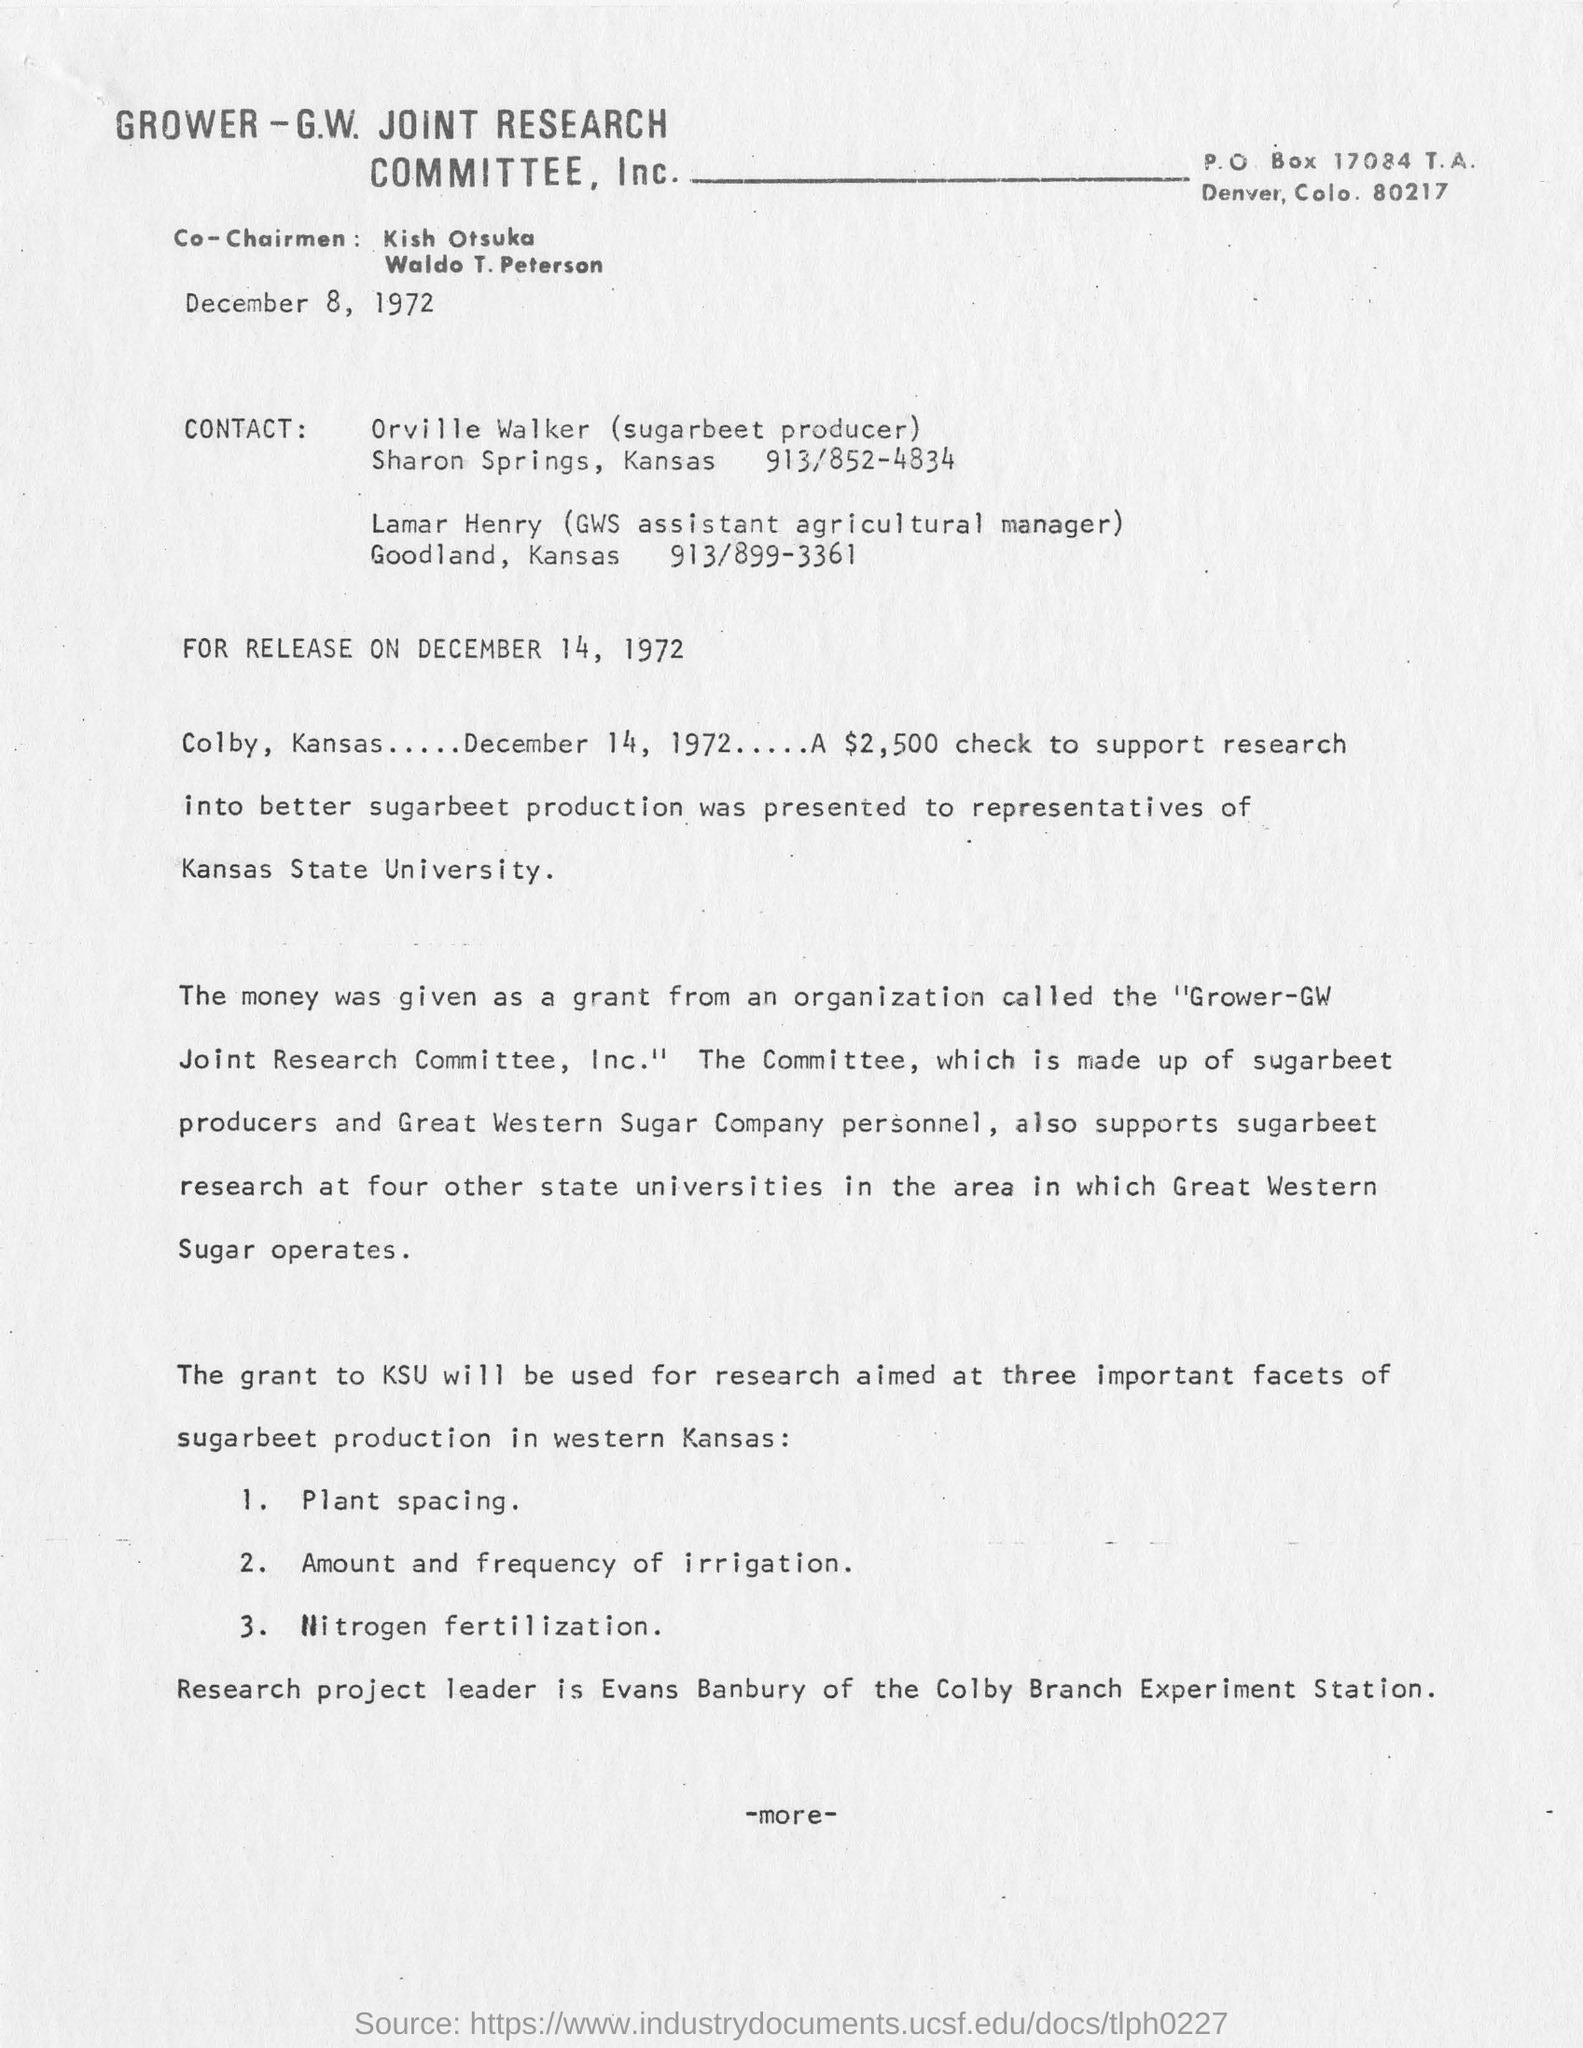When is the letter dated?
Your answer should be compact. December 8, 1972. Who is the GWS assistant agricultural manager , Goodland , Kansas?
Your response must be concise. Lamar Henry. Who is the Research project leader?
Your response must be concise. Evans Banbury of the Colby Branch Experiment Station. Why is a $2,500 check was presented to representatives of Kansas State University?
Ensure brevity in your answer.  To support research into better sugarbeet production. 